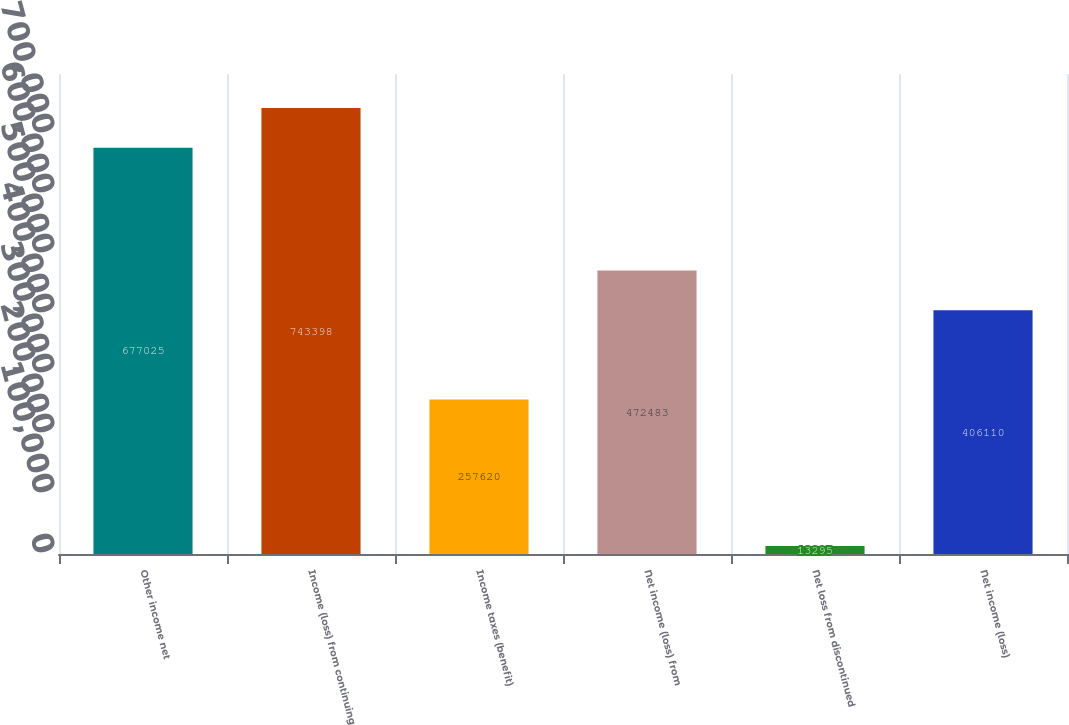Convert chart. <chart><loc_0><loc_0><loc_500><loc_500><bar_chart><fcel>Other income net<fcel>Income (loss) from continuing<fcel>Income taxes (benefit)<fcel>Net income (loss) from<fcel>Net loss from discontinued<fcel>Net income (loss)<nl><fcel>677025<fcel>743398<fcel>257620<fcel>472483<fcel>13295<fcel>406110<nl></chart> 